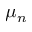Convert formula to latex. <formula><loc_0><loc_0><loc_500><loc_500>\mu _ { n }</formula> 